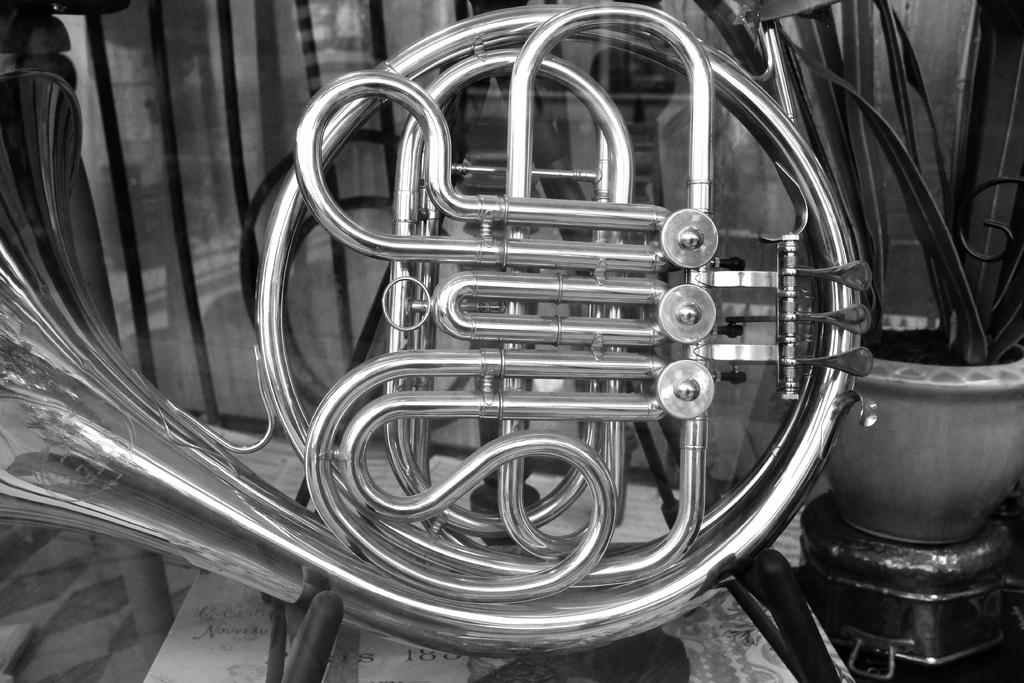What is the main object in the image? There is a saxophone in the image. Where is the saxophone located in the image? The saxophone is in the middle of the image. What can be seen on the right side of the image? There are plants on the right side of the image. What type of rifle is being used in the battle depicted in the image? There is no rifle or battle present in the image; it features a saxophone and plants. Can you tell me which soldier's ear is being targeted in the image? There are no soldiers or ears present in the image; it features a saxophone and plants. 